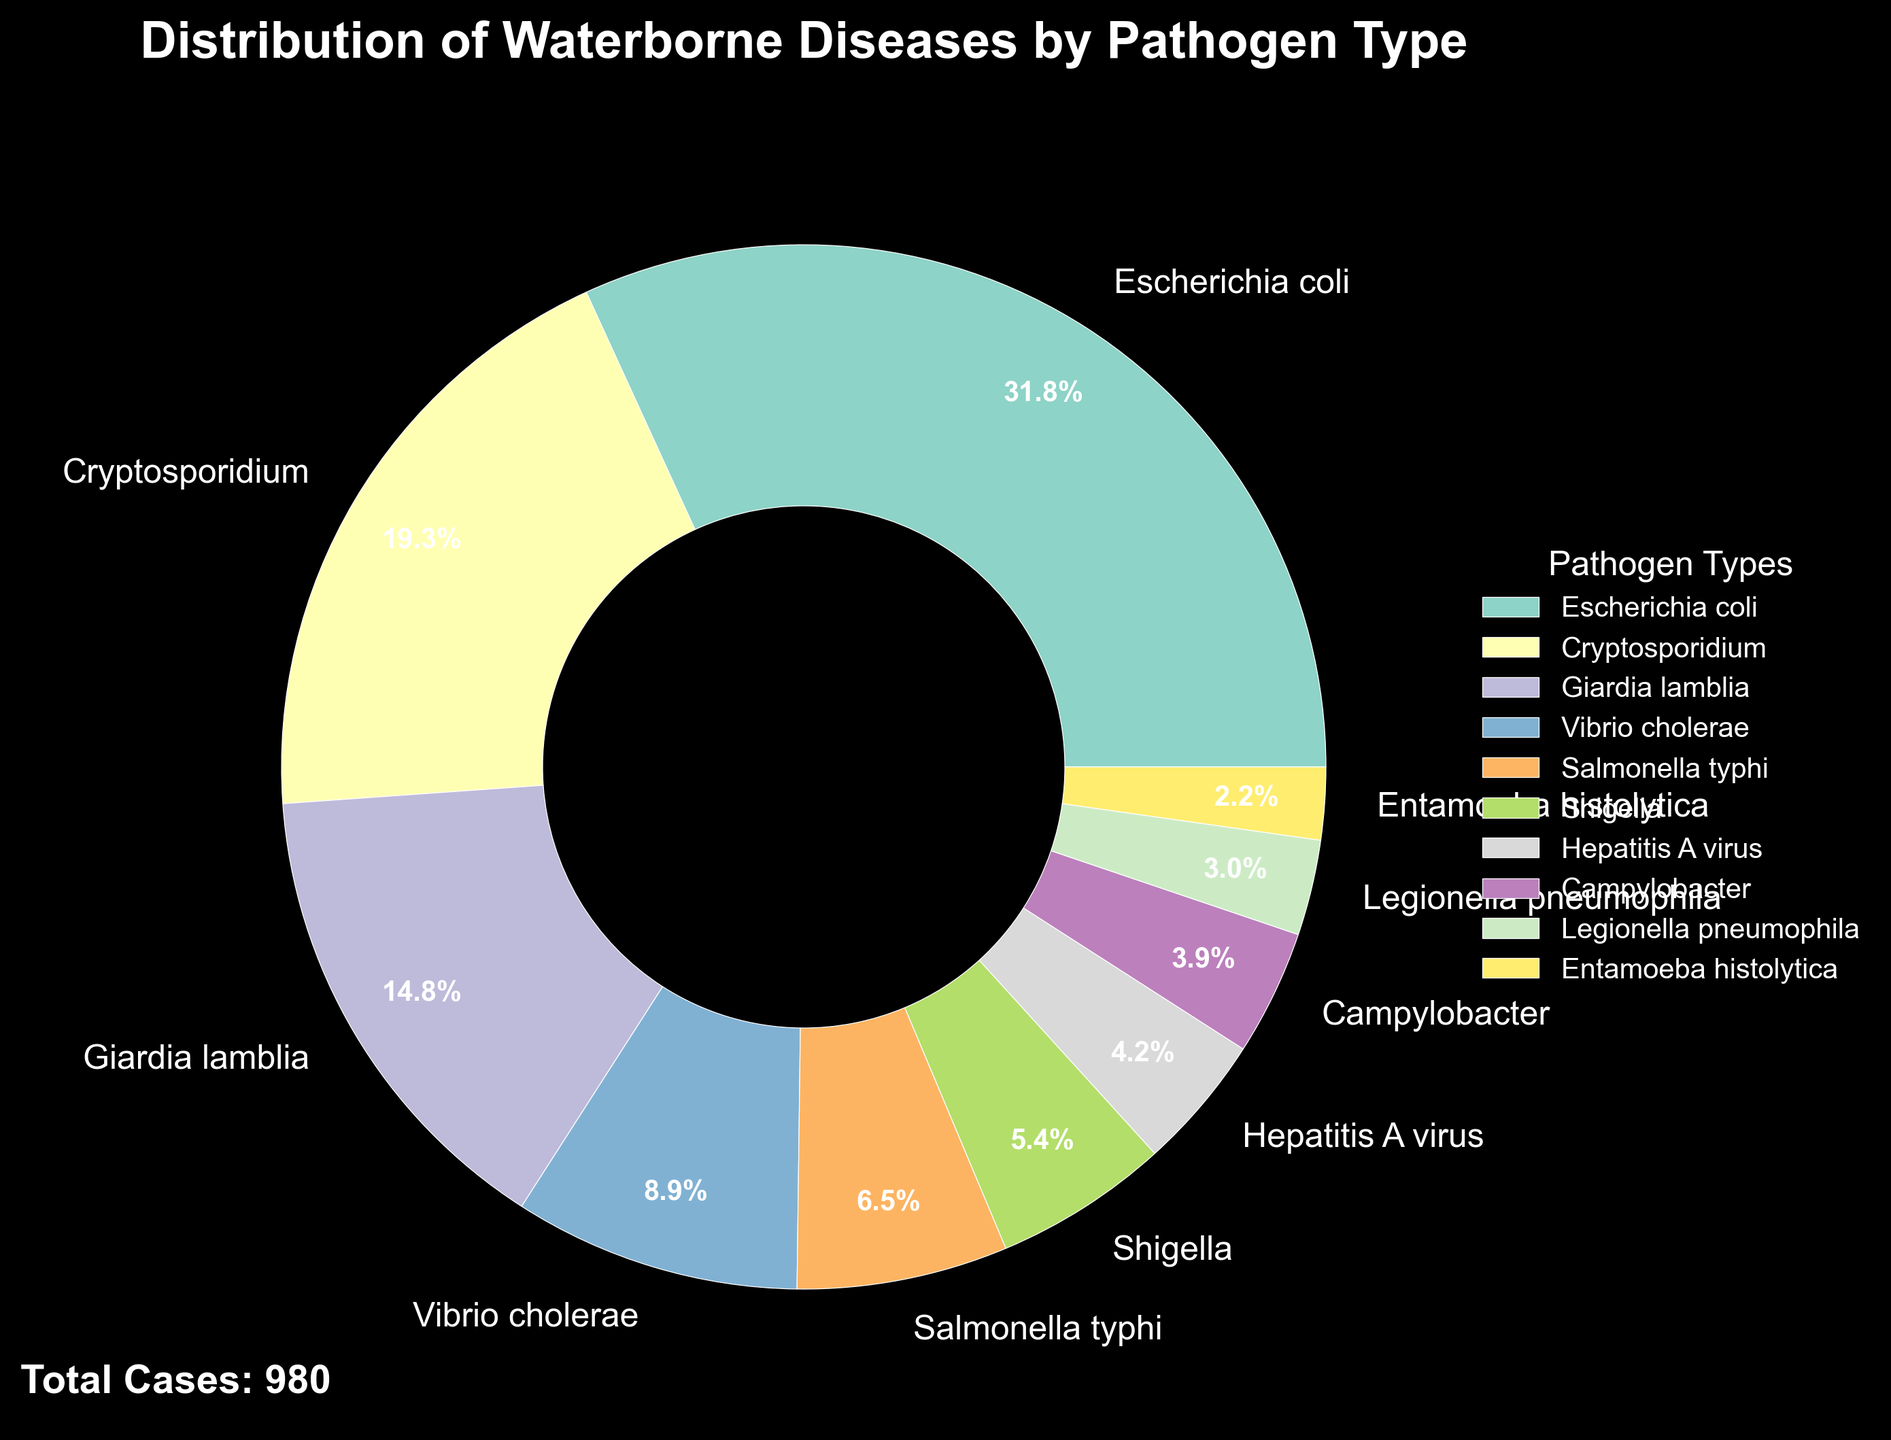What percentage of waterborne diseases is caused by Escherichia coli? Identify the wedge labeled "Escherichia coli" in the pie chart and note the percentage value displayed within or next to that wedge.
Answer: 26.1% Which pathogen type has the second highest number of reported cases? Look for the second largest wedge after "Escherichia coli", which is labeled with its percentage value.
Answer: Cryptosporidium What is the combined percentage of cases caused by Vibrio cholerae and Salmonella typhi? Find the percentage values for Vibrio cholerae and Salmonella typhi and add them together (7.3% + 5.3%).
Answer: 12.6% Which pathogen type has the lowest number of cases, and what percentage does it represent? Identify the smallest wedge, which is labeled "Entamoeba histolytica", and note its percentage value.
Answer: Entamoeba histolytica, 1.8% How many more cases are reported for Cryptosporidium than for Giardia lamblia? Find the number of cases for both Cryptosporidium (189) and Giardia lamblia (145), then subtract the latter from the former (189 - 145).
Answer: 44 What proportion of total cases is caused by top three pathogens combined? Sum the number of cases for Escherichia coli, Cryptosporidium, and Giardia lamblia (312 + 189 + 145), divide by the total number of cases (980), and multiply by 100 to get the percentage.
Answer: 65% Compare the number of cases caused by Salmonella typhi and Campylobacter. Which one has more cases and by how many? Find the number of cases for Salmonella typhi (64) and Campylobacter (38), then subtract the latter from the former to find the difference (64 - 38).
Answer: Salmonella typhi, 26 What is the total number of cases reported for pathogens with less than 50 cases each? Sum the number of cases for Shigella (53), Hepatitis A virus (41), Campylobacter (38), Legionella pneumophila (29), and Entamoeba histolytica (22).
Answer: 183 Estimate the average number of cases among all the pathogens listed. Divide the total number of cases (980) by the number of pathogen types (10).
Answer: 98 